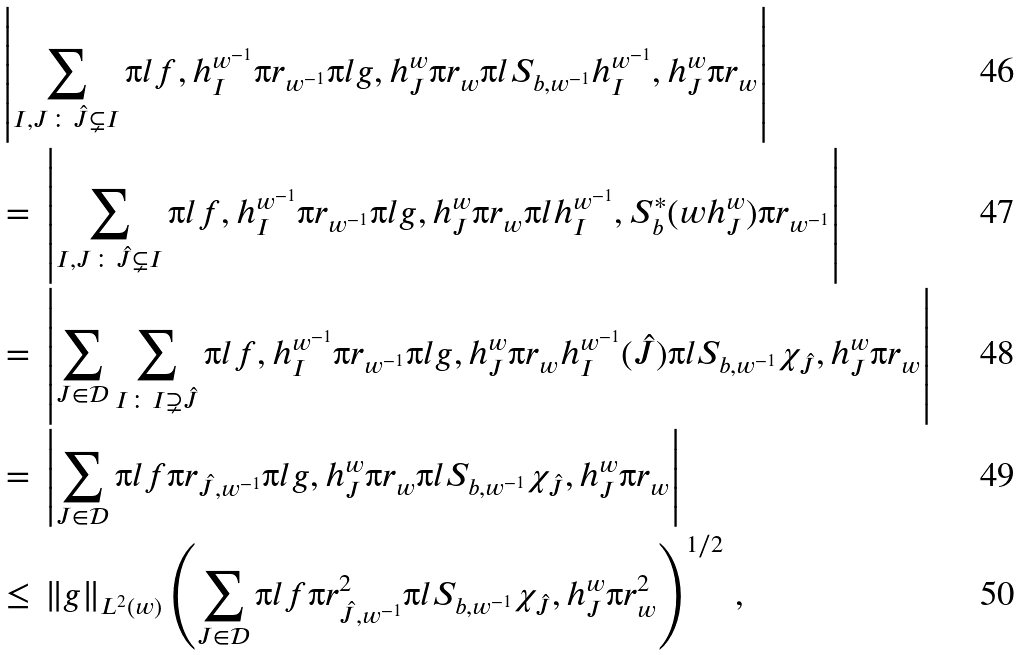Convert formula to latex. <formula><loc_0><loc_0><loc_500><loc_500>& \left | \sum _ { I , J \colon \hat { J } \subsetneq I } \i l f , h ^ { w ^ { - 1 } } _ { I } \i r _ { w ^ { - 1 } } \i l g , h ^ { w } _ { J } \i r _ { w } \i l S _ { b , w ^ { - 1 } } h ^ { w ^ { - 1 } } _ { I } , h ^ { w } _ { J } \i r _ { w } \right | \\ & = \, \left | \sum _ { I , J \colon \hat { J } \subsetneq I } \i l f , h ^ { w ^ { - 1 } } _ { I } \i r _ { w ^ { - 1 } } \i l g , h ^ { w } _ { J } \i r _ { w } \i l h ^ { w ^ { - 1 } } _ { I } , S ^ { \ast } _ { b } ( w h ^ { w } _ { J } ) \i r _ { w ^ { - 1 } } \right | \\ & = \, \left | \sum _ { J \in \mathcal { D } } \sum _ { I \colon I \supsetneq \hat { J } } \i l f , h ^ { w ^ { - 1 } } _ { I } \i r _ { w ^ { - 1 } } \i l g , h ^ { w } _ { J } \i r _ { w } h ^ { w ^ { - 1 } } _ { I } ( \hat { J } ) \i l S _ { b , w ^ { - 1 } } \chi _ { \hat { J } } , h ^ { w } _ { J } \i r _ { w } \right | \\ & = \, \left | \sum _ { J \in \mathcal { D } } \i l f \i r _ { \hat { J } , w ^ { - 1 } } \i l g , h ^ { w } _ { J } \i r _ { w } \i l S _ { b , w ^ { - 1 } } \chi _ { \hat { J } } , h ^ { w } _ { J } \i r _ { w } \right | \\ & \leq \, \| g \| _ { L ^ { 2 } ( w ) } \left ( \sum _ { J \in \mathcal { D } } \i l f \i r ^ { 2 } _ { \hat { J } , w ^ { - 1 } } \i l S _ { b , w ^ { - 1 } } \chi _ { \hat { J } } , h ^ { w } _ { J } \i r ^ { 2 } _ { w } \right ) ^ { 1 / 2 } \, ,</formula> 